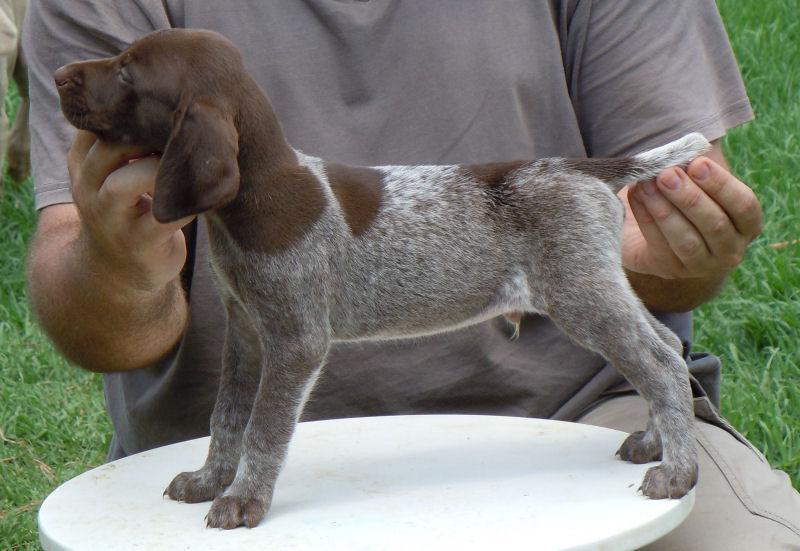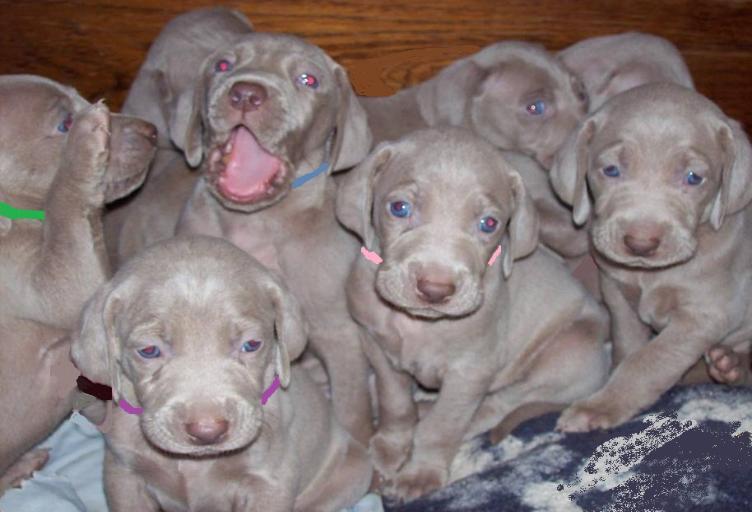The first image is the image on the left, the second image is the image on the right. Evaluate the accuracy of this statement regarding the images: "There is one dog in the left image and multiple dogs in the right image.". Is it true? Answer yes or no. Yes. The first image is the image on the left, the second image is the image on the right. Given the left and right images, does the statement "One image shows a single puppy while the other shows a litter of at least five." hold true? Answer yes or no. Yes. 